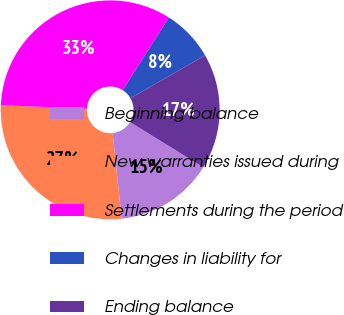<chart> <loc_0><loc_0><loc_500><loc_500><pie_chart><fcel>Beginning balance<fcel>New warranties issued during<fcel>Settlements during the period<fcel>Changes in liability for<fcel>Ending balance<nl><fcel>14.53%<fcel>27.35%<fcel>33.33%<fcel>7.69%<fcel>17.09%<nl></chart> 